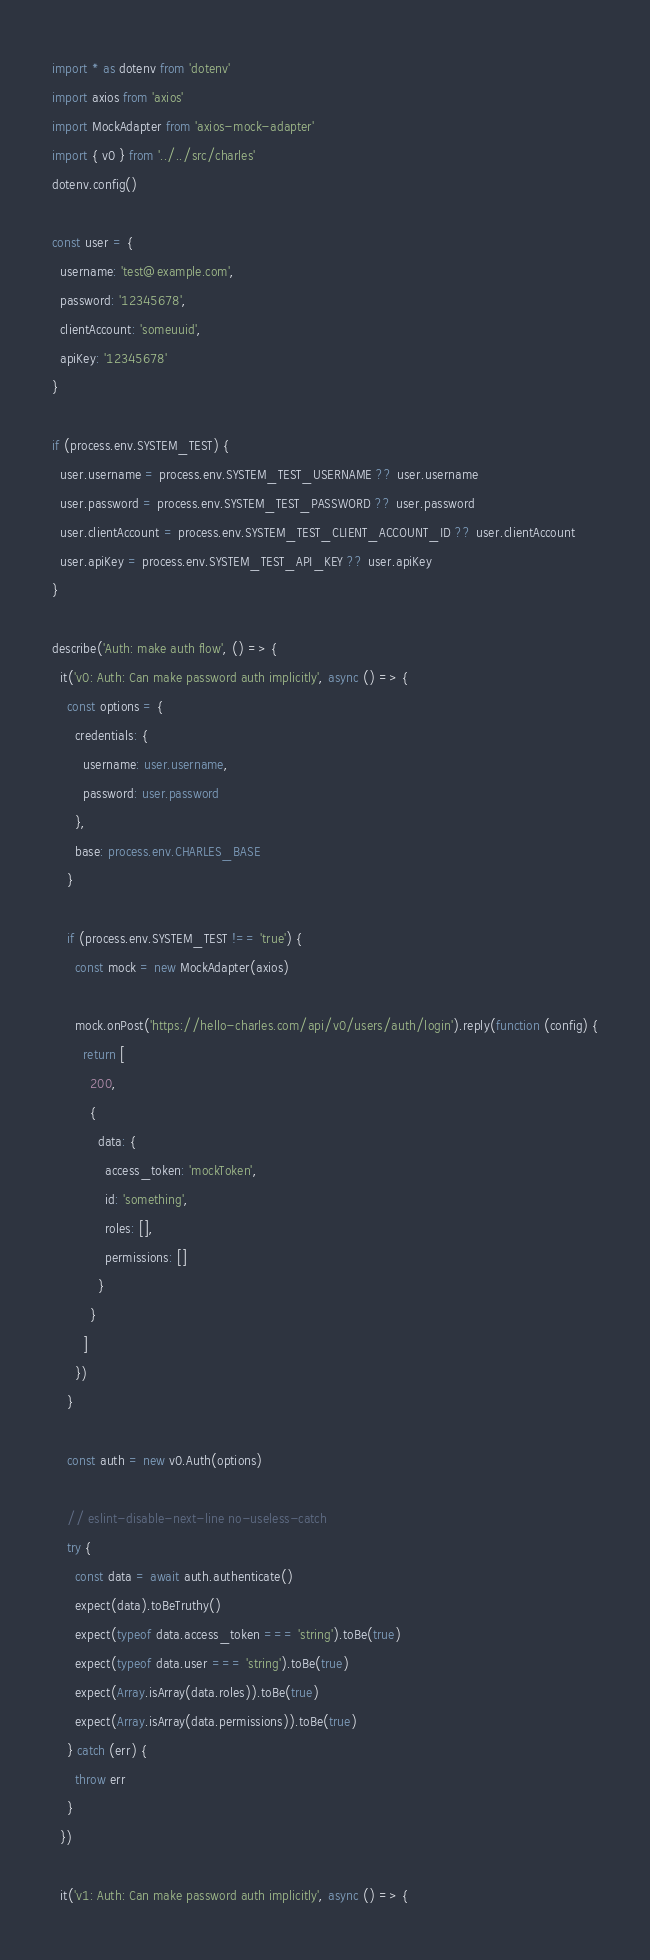<code> <loc_0><loc_0><loc_500><loc_500><_TypeScript_>import * as dotenv from 'dotenv'
import axios from 'axios'
import MockAdapter from 'axios-mock-adapter'
import { v0 } from '../../src/charles'
dotenv.config()

const user = {
  username: 'test@example.com',
  password: '12345678',
  clientAccount: 'someuuid',
  apiKey: '12345678'
}

if (process.env.SYSTEM_TEST) {
  user.username = process.env.SYSTEM_TEST_USERNAME ?? user.username
  user.password = process.env.SYSTEM_TEST_PASSWORD ?? user.password
  user.clientAccount = process.env.SYSTEM_TEST_CLIENT_ACCOUNT_ID ?? user.clientAccount
  user.apiKey = process.env.SYSTEM_TEST_API_KEY ?? user.apiKey
}

describe('Auth: make auth flow', () => {
  it('v0: Auth: Can make password auth implicitly', async () => {
    const options = {
      credentials: {
        username: user.username,
        password: user.password
      },
      base: process.env.CHARLES_BASE
    }

    if (process.env.SYSTEM_TEST !== 'true') {
      const mock = new MockAdapter(axios)

      mock.onPost('https://hello-charles.com/api/v0/users/auth/login').reply(function (config) {
        return [
          200,
          {
            data: {
              access_token: 'mockToken',
              id: 'something',
              roles: [],
              permissions: []
            }
          }
        ]
      })
    }

    const auth = new v0.Auth(options)

    // eslint-disable-next-line no-useless-catch
    try {
      const data = await auth.authenticate()
      expect(data).toBeTruthy()
      expect(typeof data.access_token === 'string').toBe(true)
      expect(typeof data.user === 'string').toBe(true)
      expect(Array.isArray(data.roles)).toBe(true)
      expect(Array.isArray(data.permissions)).toBe(true)
    } catch (err) {
      throw err
    }
  })

  it('v1: Auth: Can make password auth implicitly', async () => {</code> 